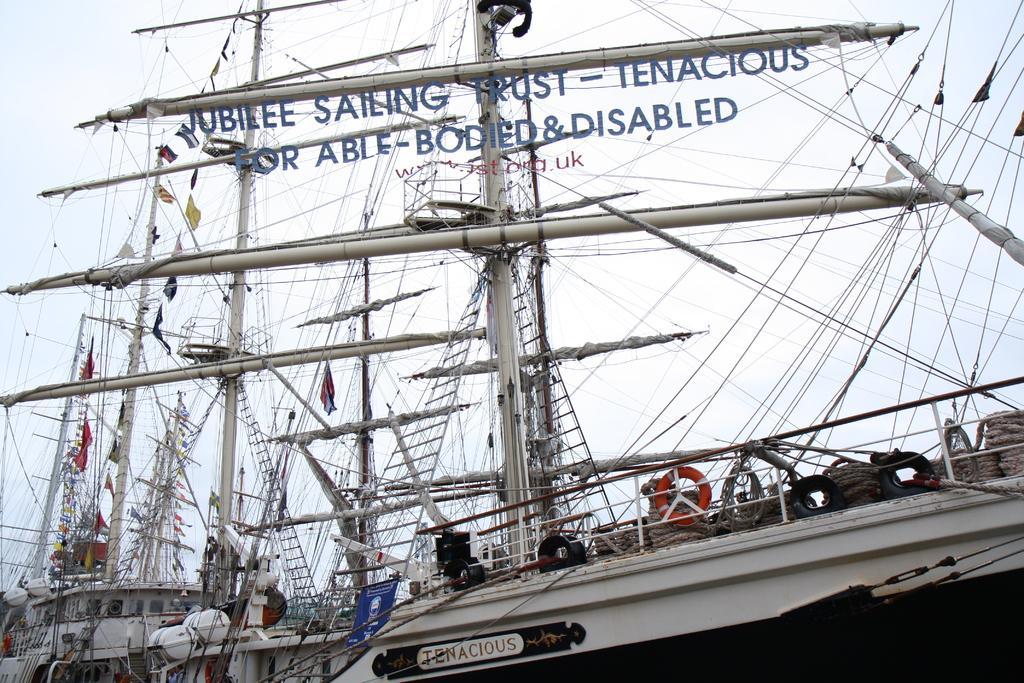In one or two sentences, can you explain what this image depicts? In this image in the middle, there are boats, tubes, cables, ropes, flags, text. In the background there is the sky. 